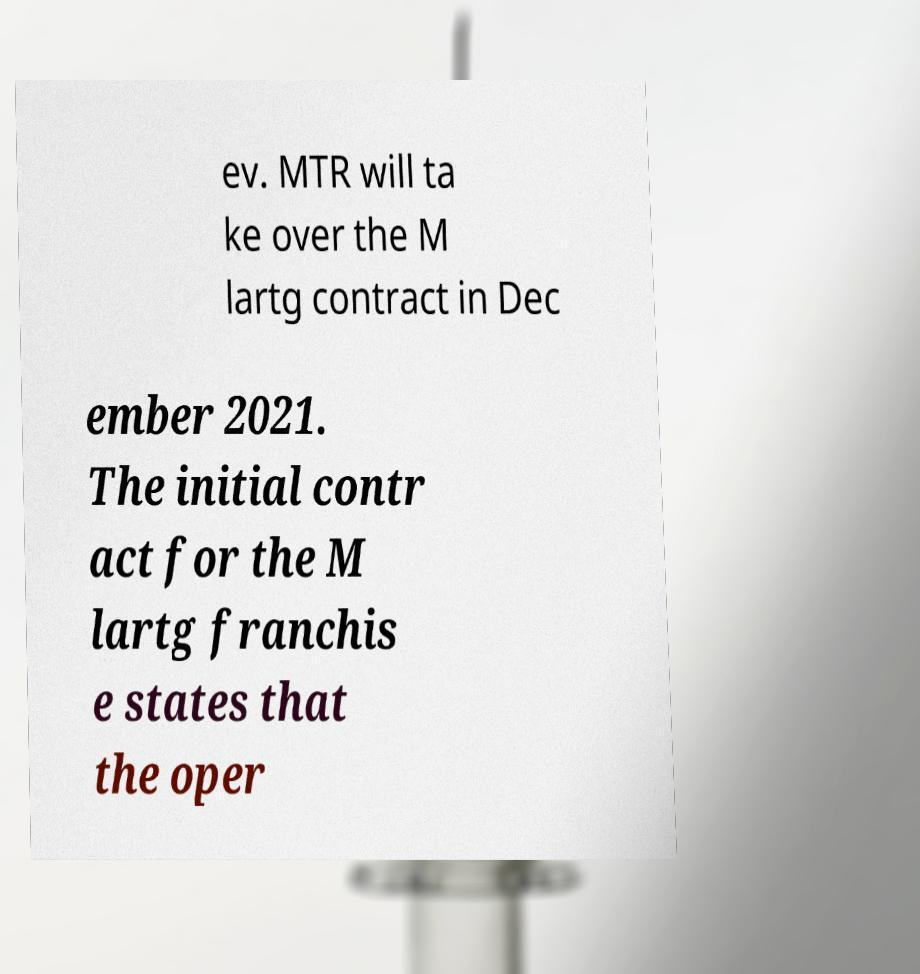Please identify and transcribe the text found in this image. ev. MTR will ta ke over the M lartg contract in Dec ember 2021. The initial contr act for the M lartg franchis e states that the oper 